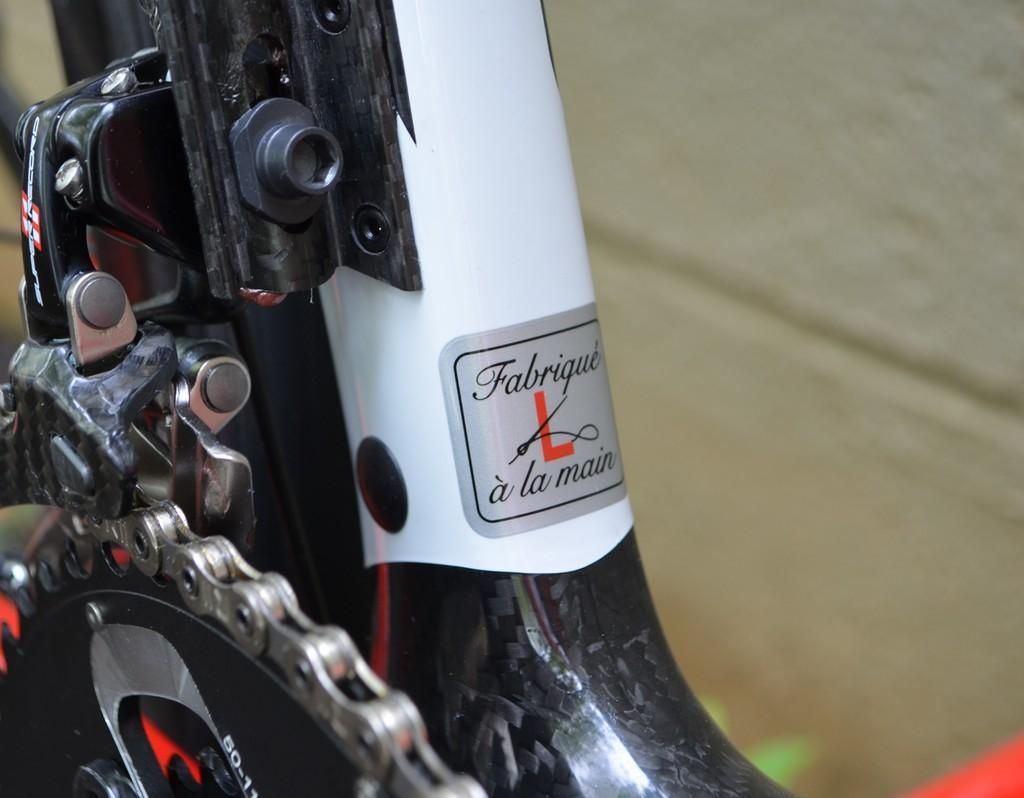What is the main object in the image? There is a frame in the image. What part of a machine or mechanism can be seen in the image? There is a crank in the image. What type of object is associated with a bicycle in the image? There is a chain of a bicycle in the image. How would you describe the background of the image? The background of the image is blurred. Is there a drawer in the image that someone can open to store items? There is no drawer present in the image. Can you see any writing on the frame or any of the other objects in the image? There is no visible writing on any of the objects in the image. 